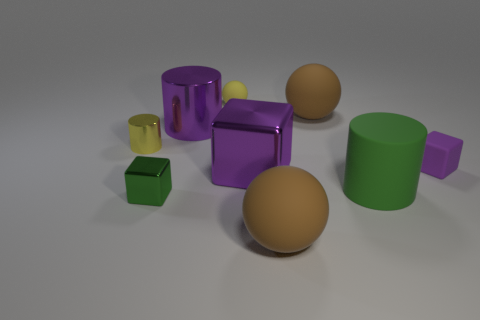What color is the tiny matte object that is the same shape as the green metal thing?
Your answer should be compact. Purple. Are there any other things that have the same shape as the tiny yellow shiny object?
Ensure brevity in your answer.  Yes. Does the cylinder that is to the left of the small green object have the same color as the tiny matte sphere?
Provide a succinct answer. Yes. What size is the other shiny thing that is the same shape as the tiny green metallic thing?
Ensure brevity in your answer.  Large. How many tiny red objects are made of the same material as the green cylinder?
Give a very brief answer. 0. There is a large purple object that is in front of the purple thing that is behind the tiny rubber cube; is there a big purple metal object that is behind it?
Offer a very short reply. Yes. What is the shape of the big green matte thing?
Make the answer very short. Cylinder. Is the large brown sphere that is behind the purple metal cube made of the same material as the big purple object that is behind the rubber block?
Your answer should be very brief. No. What number of tiny cylinders are the same color as the small matte ball?
Your response must be concise. 1. The metal object that is to the left of the big metal cylinder and behind the tiny purple block has what shape?
Give a very brief answer. Cylinder. 